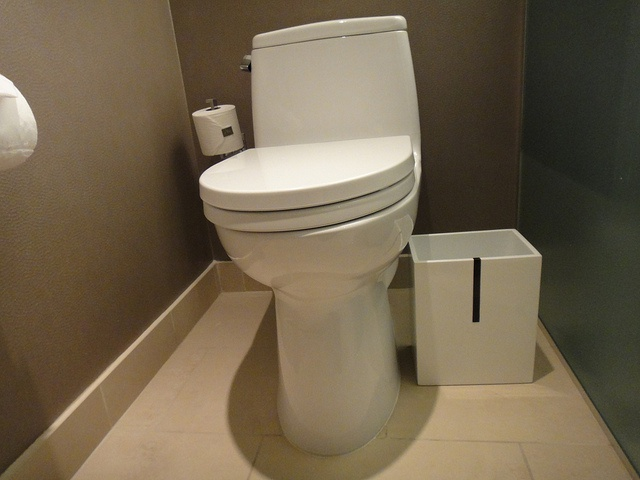Describe the objects in this image and their specific colors. I can see a toilet in gray, darkgray, and ivory tones in this image. 